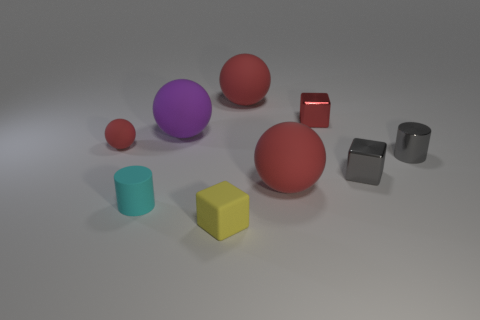Subtract all cyan blocks. How many red balls are left? 3 Add 1 metal things. How many objects exist? 10 Subtract all cubes. How many objects are left? 6 Subtract all spheres. Subtract all big matte balls. How many objects are left? 2 Add 9 large purple rubber things. How many large purple rubber things are left? 10 Add 6 small cyan cylinders. How many small cyan cylinders exist? 7 Subtract 0 blue cylinders. How many objects are left? 9 